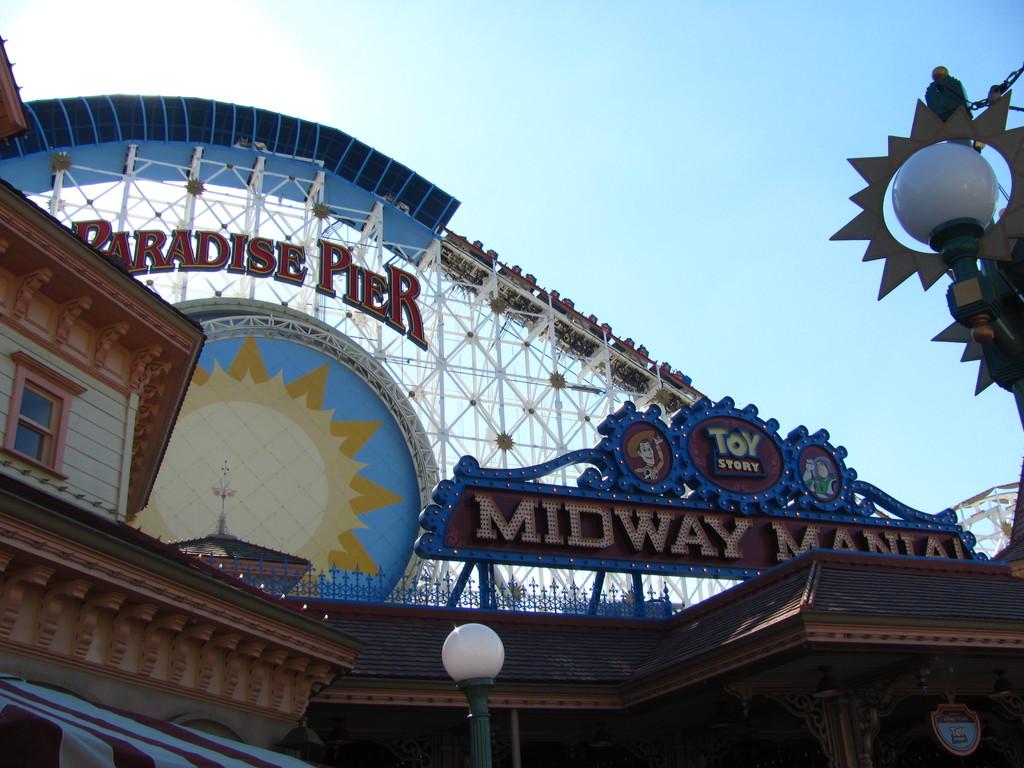What pier is this?
Make the answer very short. Paradise pier. What movie is displayed above the midway sign?
Provide a succinct answer. Toy story. 